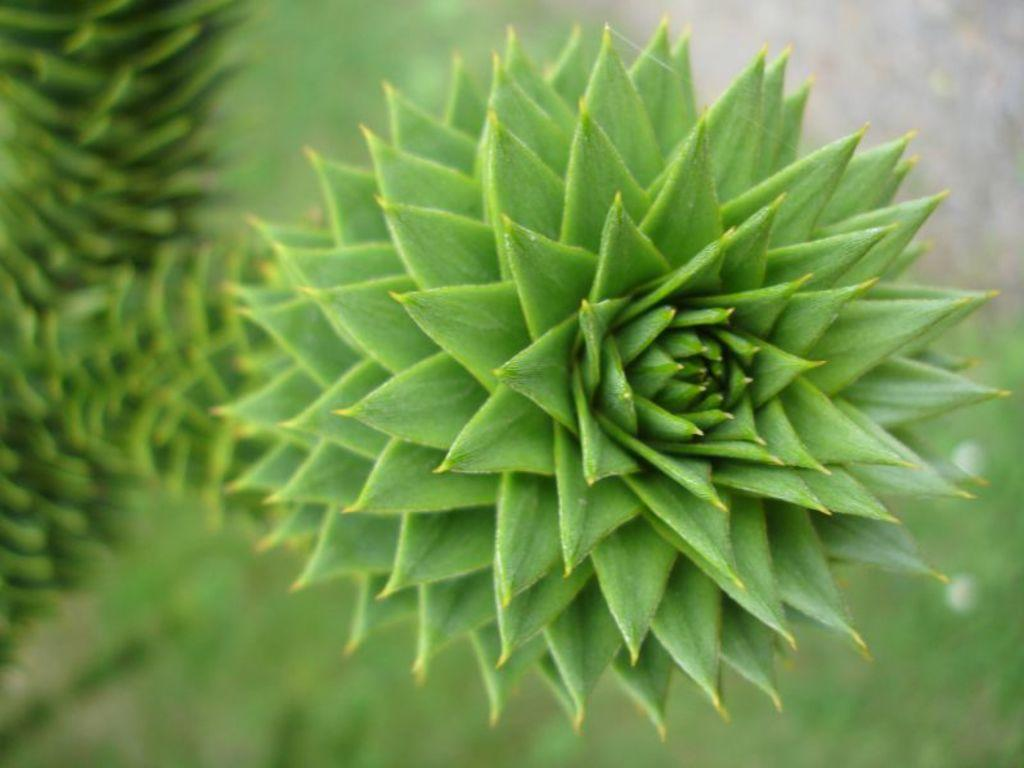What is present in the image? There is a plant in the image. What can be said about the color of the plant? The plant is green in color. What is the name of the giant in the image? There are no giants present in the image; it only features a green plant. How many ants can be seen crawling on the plant in the image? There are no ants visible in the image; it only features a green plant. 